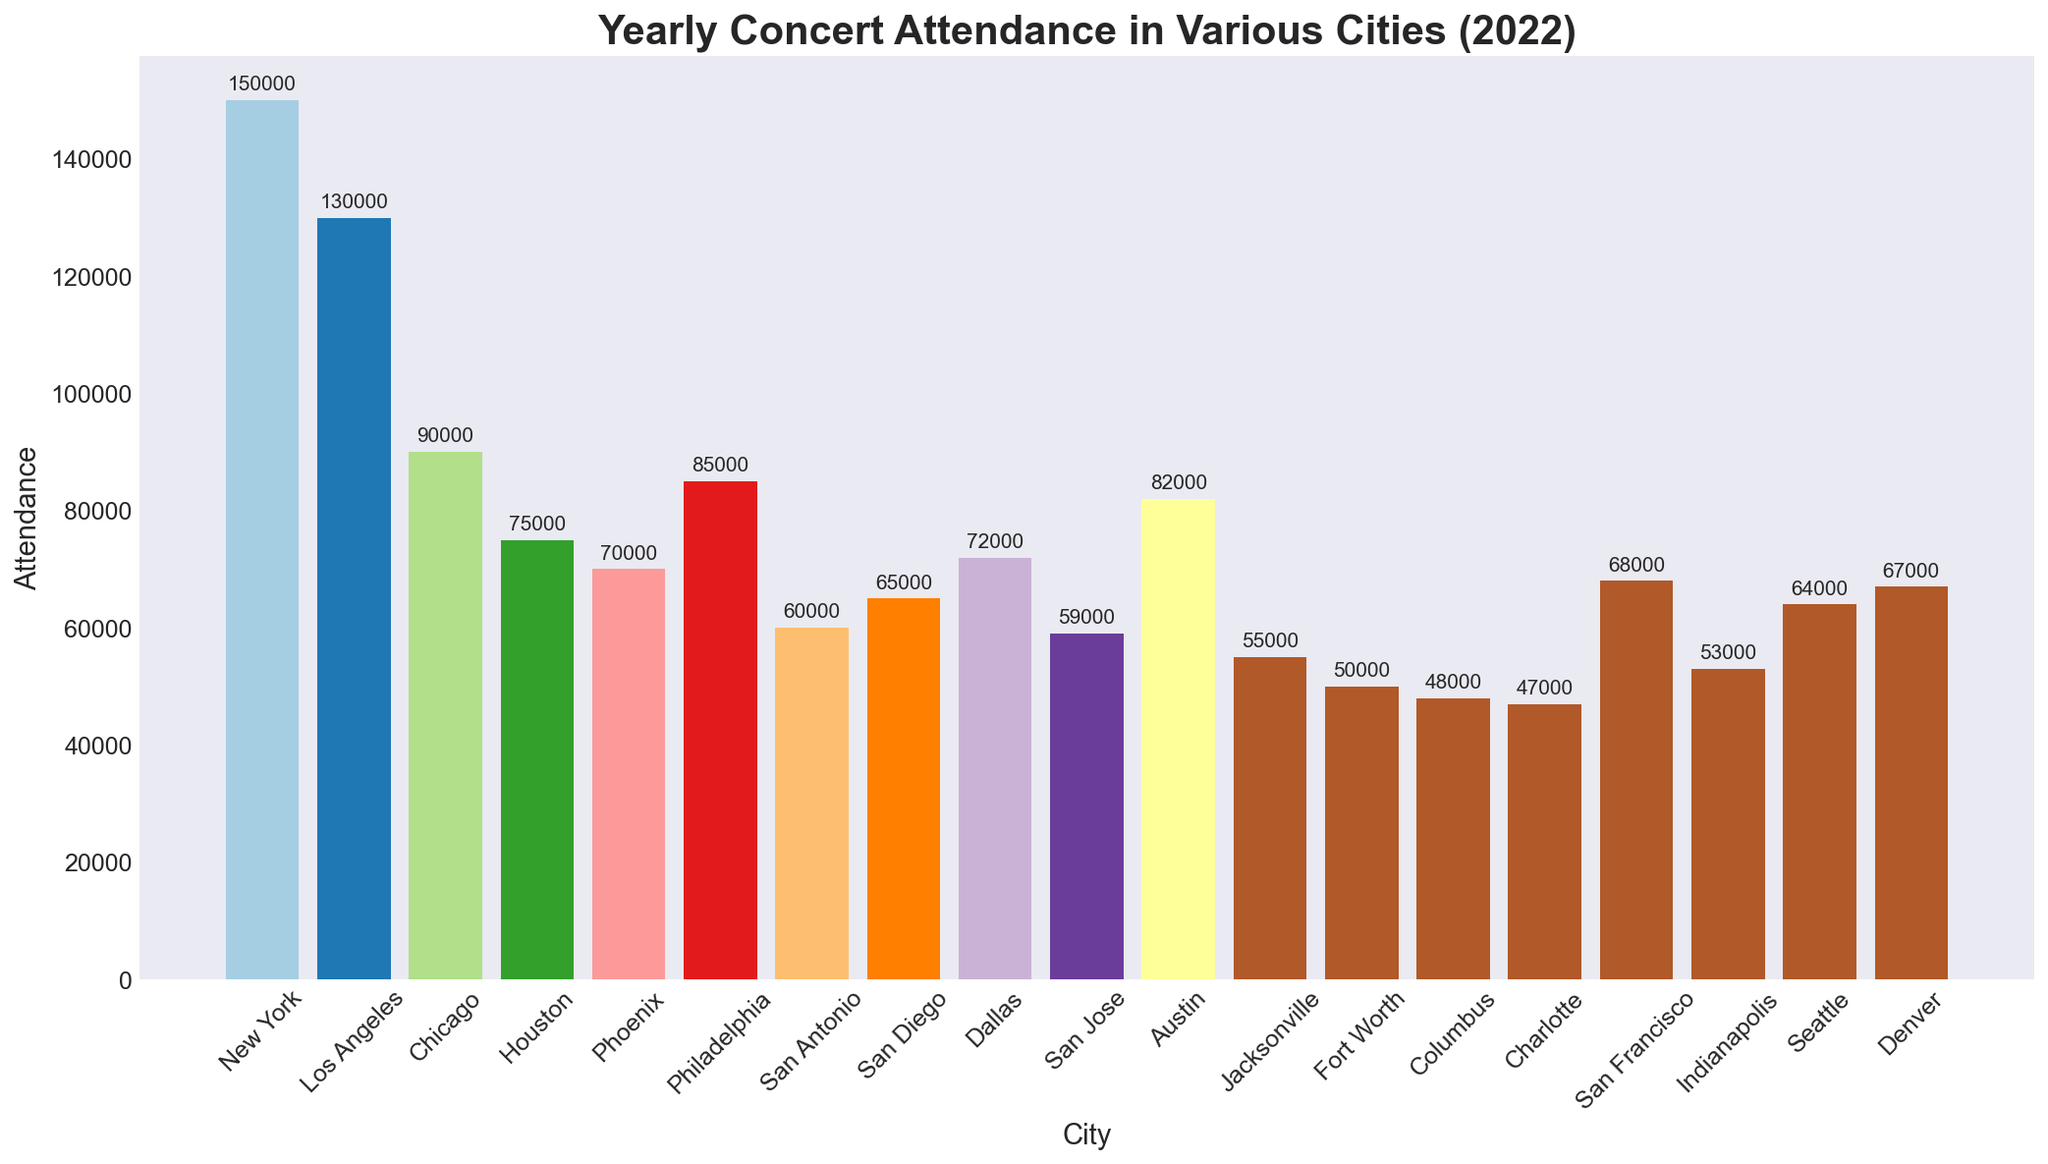Which city had the highest concert attendance in 2022? To determine the city with the highest concert attendance, visually compare the heights of the bars in the chart. The tallest bar represents New York.
Answer: New York What is the difference in concert attendance between New York and Los Angeles? First, find the attendance numbers for both cities: New York (150,000) and Los Angeles (130,000). Subtract the attendance of Los Angeles from New York: 150,000 - 130,000 = 20,000.
Answer: 20,000 Which cities had concert attendance figures of fewer than 60,000? Identify the cities associated with bars shorter than the indicated level for 60,000 attendees. These cities are Jacksonville, Fort Worth, Columbus, Charlotte, San Jose, and Indianapolis.
Answer: Jacksonville, Fort Worth, Columbus, Charlotte, San Jose, Indianapolis How much higher was the concert attendance in Philadelphia compared to San Francisco? Note the attendance for Philadelphia (85,000) and San Francisco (68,000). Calculate the difference: 85,000 - 68,000 = 17,000.
Answer: 17,000 What is the average concert attendance across the top three cities? The top three cities based on bar height are New York (150,000), Los Angeles (130,000), and Chicago (90,000). Calculate the average: (150,000 + 130,000 + 90,000) / 3 = 370,000 / 3 ≈ 123,333.
Answer: 123,333 Which city had the closest concert attendance to 70,000? Identify the bar closest in height to 70,000. San Diego is the closest with an attendance of 65,000.
Answer: San Diego How many cities had concert attendance figures higher than 80,000? Count the bars taller than the 80,000 mark. Cities with attendance above 80,000 are New York (150,000), Los Angeles (130,000), Philadelphia (85,000), and Chicago (90,000). Therefore, there are four such cities.
Answer: 4 If we combine the concert attendance of Houston and Austin, what is the total? Find and sum the attendance for Houston (75,000) and Austin (82,000): 75,000 + 82,000 = 157,000.
Answer: 157,000 What percentage of the total concert attendance did New York represent? First, sum all the city attendances, then calculate New York's share: Total = 1,194,000. New York's attendance = 150,000. Percentage = (150,000 / 1,194,000) * 100 ≈ 12.56%.
Answer: 12.56% How did Seattle's concert attendance compare to San Diego's? Look at the bars representing Seattle (64,000) and San Diego (65,000). Seattle's attendance is slightly lower than San Diego’s by 1,000.
Answer: Slightly lower 